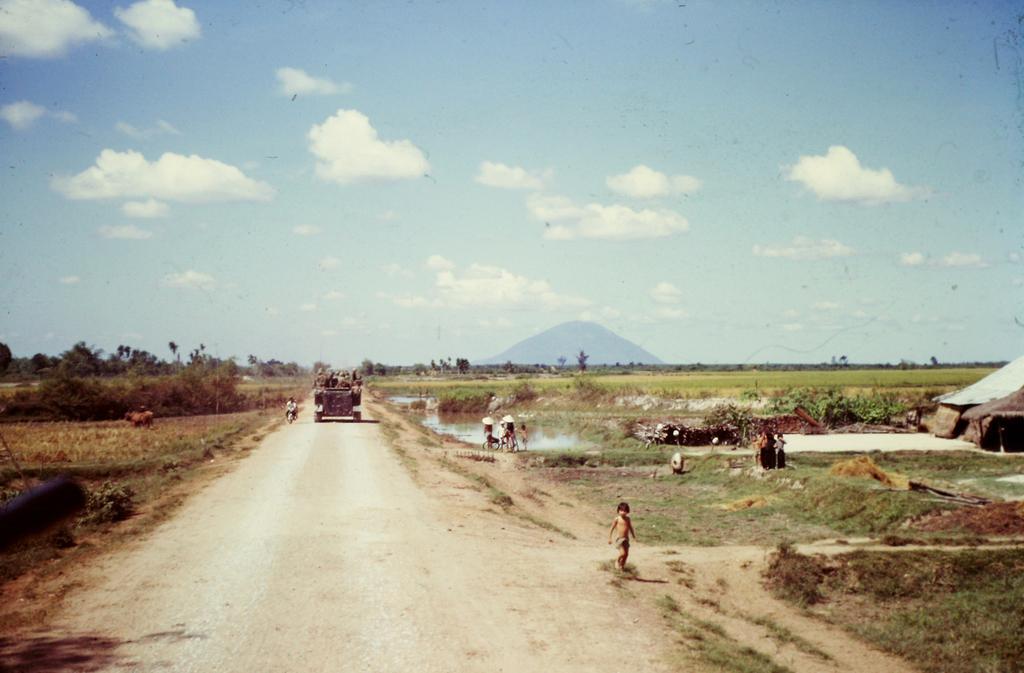How would you summarize this image in a sentence or two? In this image I can see the vehicle on the road. I can see few people in the vehicle. To the right I can see few more people. On both sides I can see the grass and plants. To the right I can see the hut. In the background I can see the trees, mountain, clouds and the sky. 